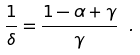<formula> <loc_0><loc_0><loc_500><loc_500>\frac { 1 } { \delta } = \frac { 1 - \alpha + \gamma } { \gamma } \ .</formula> 